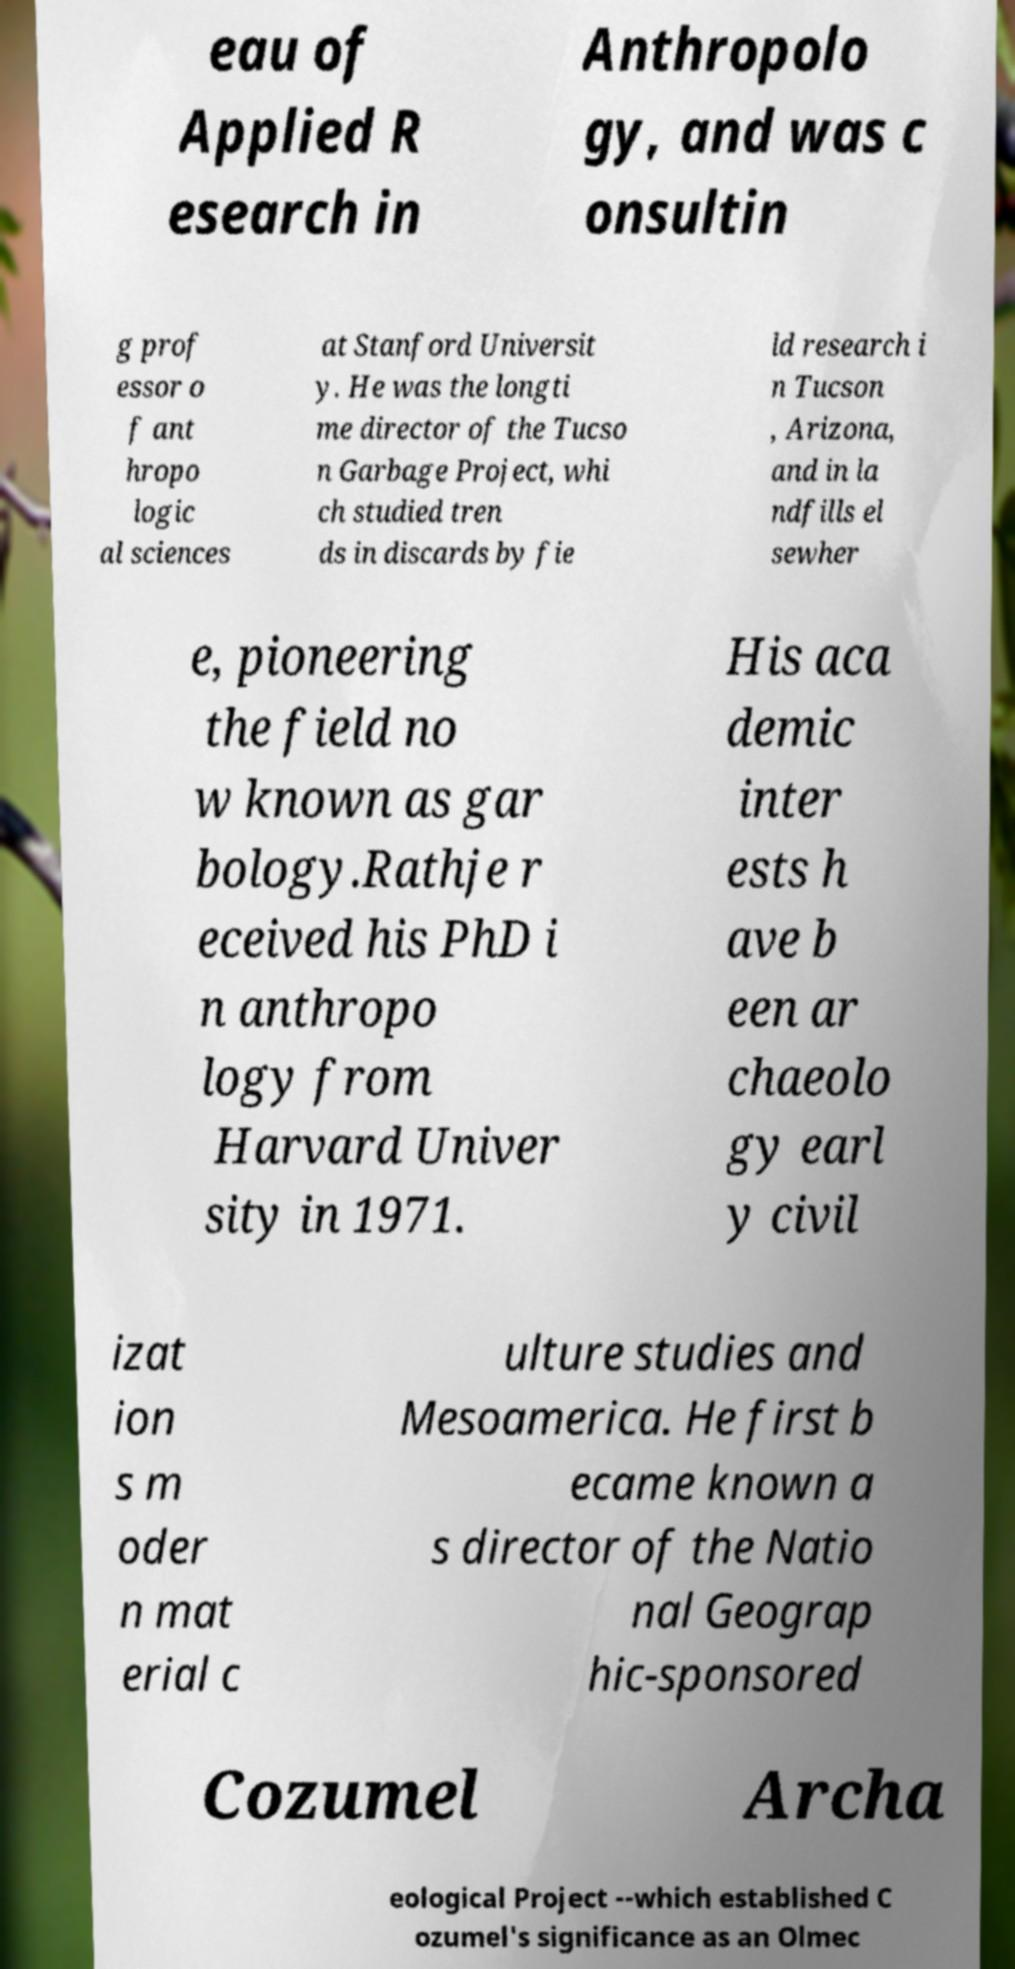Please identify and transcribe the text found in this image. eau of Applied R esearch in Anthropolo gy, and was c onsultin g prof essor o f ant hropo logic al sciences at Stanford Universit y. He was the longti me director of the Tucso n Garbage Project, whi ch studied tren ds in discards by fie ld research i n Tucson , Arizona, and in la ndfills el sewher e, pioneering the field no w known as gar bology.Rathje r eceived his PhD i n anthropo logy from Harvard Univer sity in 1971. His aca demic inter ests h ave b een ar chaeolo gy earl y civil izat ion s m oder n mat erial c ulture studies and Mesoamerica. He first b ecame known a s director of the Natio nal Geograp hic-sponsored Cozumel Archa eological Project --which established C ozumel's significance as an Olmec 